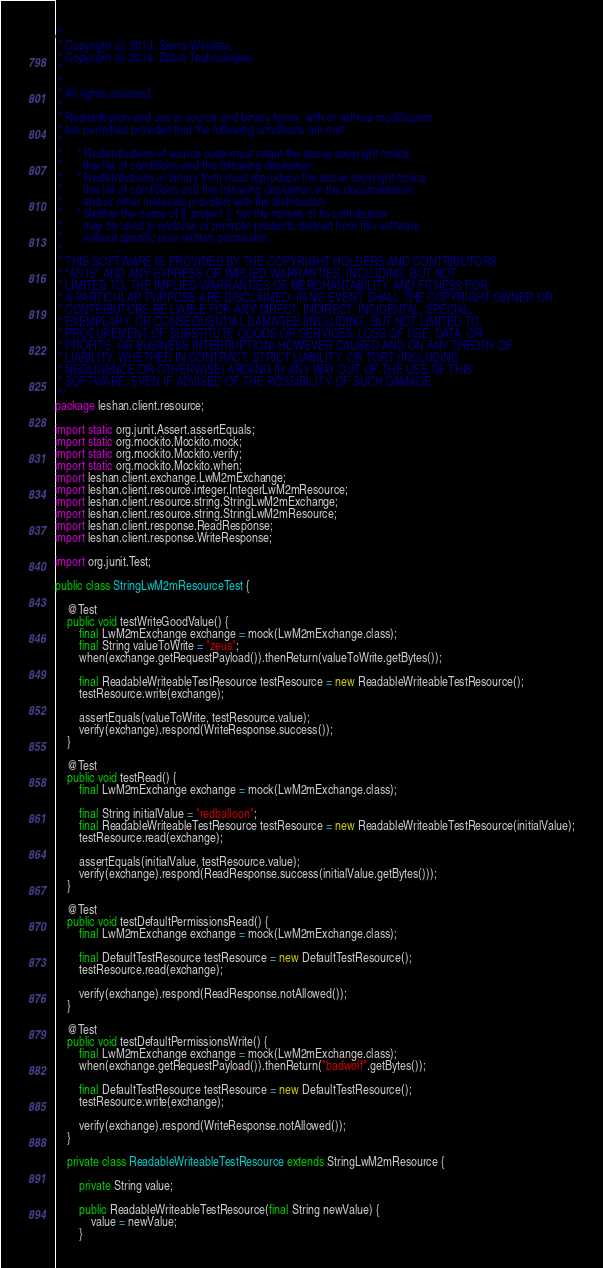Convert code to text. <code><loc_0><loc_0><loc_500><loc_500><_Java_>/*
 * Copyright (c) 2013, Sierra Wireless,
 * Copyright (c) 2014, Zebra Technologies,
 * 
 *
 * All rights reserved.
 *
 * Redistribution and use in source and binary forms, with or without modification,
 * are permitted provided that the following conditions are met:
 *
 *     * Redistributions of source code must retain the above copyright notice,
 *       this list of conditions and the following disclaimer.
 *     * Redistributions in binary form must reproduce the above copyright notice,
 *       this list of conditions and the following disclaimer in the documentation
 *       and/or other materials provided with the distribution.
 *     * Neither the name of {{ project }} nor the names of its contributors
 *       may be used to endorse or promote products derived from this software
 *       without specific prior written permission.
 *
 * THIS SOFTWARE IS PROVIDED BY THE COPYRIGHT HOLDERS AND CONTRIBUTORS
 * "AS IS" AND ANY EXPRESS OR IMPLIED WARRANTIES, INCLUDING, BUT NOT
 * LIMITED TO, THE IMPLIED WARRANTIES OF MERCHANTABILITY AND FITNESS FOR
 * A PARTICULAR PURPOSE ARE DISCLAIMED. IN NO EVENT SHALL THE COPYRIGHT OWNER OR
 * CONTRIBUTORS BE LIABLE FOR ANY DIRECT, INDIRECT, INCIDENTAL, SPECIAL,
 * EXEMPLARY, OR CONSEQUENTIAL DAMAGES (INCLUDING, BUT NOT LIMITED TO,
 * PROCUREMENT OF SUBSTITUTE GOODS OR SERVICES; LOSS OF USE, DATA, OR
 * PROFITS; OR BUSINESS INTERRUPTION) HOWEVER CAUSED AND ON ANY THEORY OF
 * LIABILITY, WHETHER IN CONTRACT, STRICT LIABILITY, OR TORT (INCLUDING
 * NEGLIGENCE OR OTHERWISE) ARISING IN ANY WAY OUT OF THE USE OF THIS
 * SOFTWARE, EVEN IF ADVISED OF THE POSSIBILITY OF SUCH DAMAGE.
 */
package leshan.client.resource;

import static org.junit.Assert.assertEquals;
import static org.mockito.Mockito.mock;
import static org.mockito.Mockito.verify;
import static org.mockito.Mockito.when;
import leshan.client.exchange.LwM2mExchange;
import leshan.client.resource.integer.IntegerLwM2mResource;
import leshan.client.resource.string.StringLwM2mExchange;
import leshan.client.resource.string.StringLwM2mResource;
import leshan.client.response.ReadResponse;
import leshan.client.response.WriteResponse;

import org.junit.Test;

public class StringLwM2mResourceTest {

    @Test
    public void testWriteGoodValue() {
        final LwM2mExchange exchange = mock(LwM2mExchange.class);
        final String valueToWrite = "zeus";
        when(exchange.getRequestPayload()).thenReturn(valueToWrite.getBytes());

        final ReadableWriteableTestResource testResource = new ReadableWriteableTestResource();
        testResource.write(exchange);

        assertEquals(valueToWrite, testResource.value);
        verify(exchange).respond(WriteResponse.success());
    }

    @Test
    public void testRead() {
        final LwM2mExchange exchange = mock(LwM2mExchange.class);

        final String initialValue = "redballoon";
        final ReadableWriteableTestResource testResource = new ReadableWriteableTestResource(initialValue);
        testResource.read(exchange);

        assertEquals(initialValue, testResource.value);
        verify(exchange).respond(ReadResponse.success(initialValue.getBytes()));
    }

    @Test
    public void testDefaultPermissionsRead() {
        final LwM2mExchange exchange = mock(LwM2mExchange.class);

        final DefaultTestResource testResource = new DefaultTestResource();
        testResource.read(exchange);

        verify(exchange).respond(ReadResponse.notAllowed());
    }

    @Test
    public void testDefaultPermissionsWrite() {
        final LwM2mExchange exchange = mock(LwM2mExchange.class);
        when(exchange.getRequestPayload()).thenReturn("badwolf".getBytes());

        final DefaultTestResource testResource = new DefaultTestResource();
        testResource.write(exchange);

        verify(exchange).respond(WriteResponse.notAllowed());
    }

    private class ReadableWriteableTestResource extends StringLwM2mResource {

        private String value;

        public ReadableWriteableTestResource(final String newValue) {
            value = newValue;
        }
</code> 